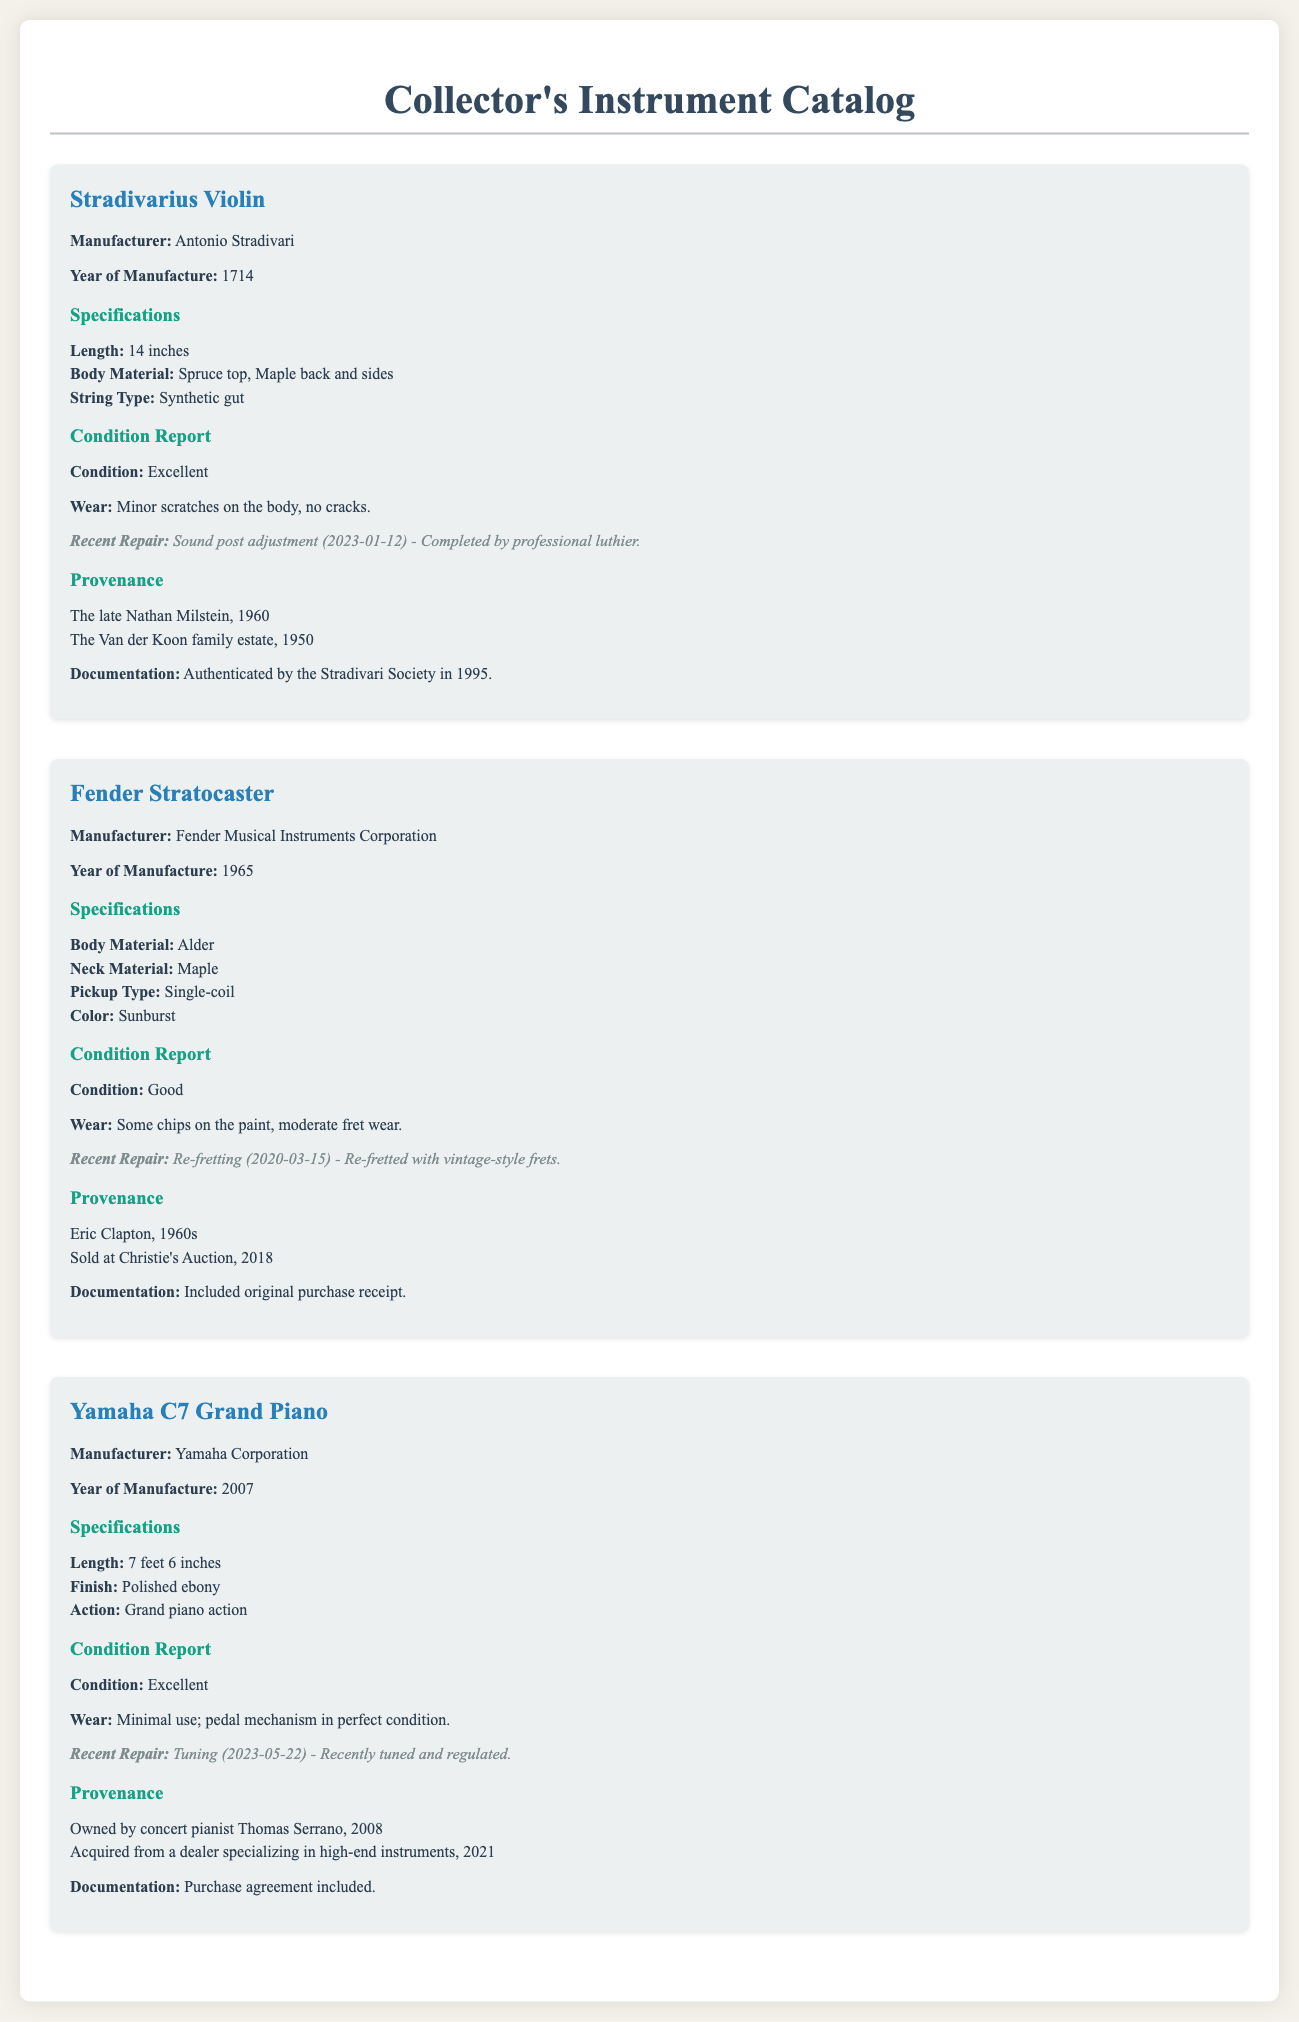What is the manufacturer of the Stradivarius Violin? The manufacturer of the Stradivarius Violin is mentioned in the specifications section of the document.
Answer: Antonio Stradivari What year was the Fender Stratocaster manufactured? The year of manufacture for the Fender Stratocaster is specified in the document.
Answer: 1965 What is the string type of the Stradivarius Violin? The string type can be found under the specifications section for the Stradivarius Violin.
Answer: Synthetic gut What is the condition of the Yamaha C7 Grand Piano? The condition of the Yamaha C7 Grand Piano is detailed in the condition report section of the document.
Answer: Excellent Who owned the Yamaha C7 Grand Piano in 2008? The provenance section lists previous ownership of the Yamaha C7 Grand Piano.
Answer: Thomas Serrano How many inches is the length of the Stradivarius Violin? The length of the Stradivarius Violin is specified in the specifications section.
Answer: 14 inches What recent repair was done to the Fender Stratocaster? The recent repair is noted in the condition report for the Fender Stratocaster.
Answer: Re-fretting What is the body material of the Fender Stratocaster? The body material is found in the specifications section of the Fender Stratocaster.
Answer: Alder How many feet long is the Yamaha C7 Grand Piano? The length of the Yamaha C7 Grand Piano is specified in the specifications section.
Answer: 7 feet 6 inches 